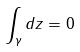Convert formula to latex. <formula><loc_0><loc_0><loc_500><loc_500>\int _ { \gamma } d z = 0</formula> 